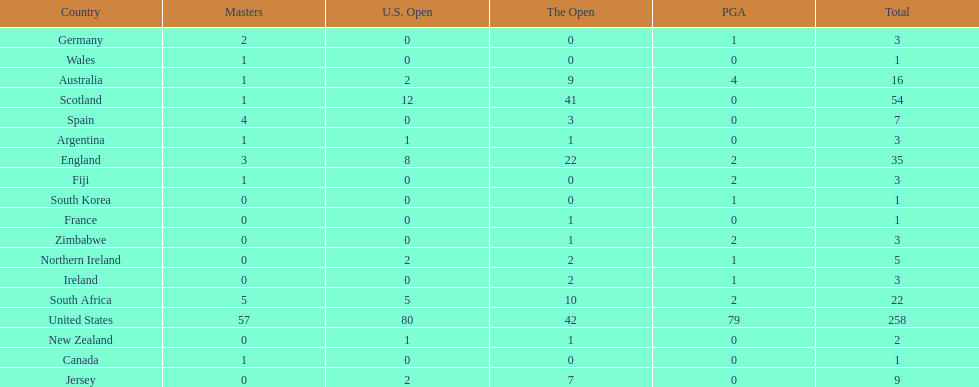What countries in the championship were from africa? South Africa, Zimbabwe. Which of these counteries had the least championship golfers Zimbabwe. 